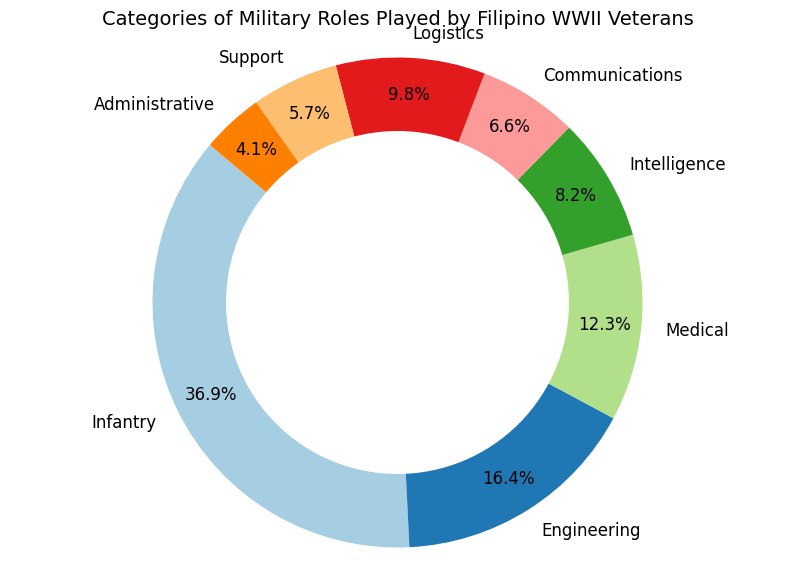Which category has the highest percentage of roles played by Filipino WWII veterans? By looking at the pie chart, the category with the largest segment represents the highest percentage. In this case, it is the Infantry category.
Answer: Infantry Which categories together compose roughly half of the total roles? Adding the percentages of the two largest segments, Infantry (45%) and Engineering (20%), gives us 65%. So, Infantry and Engineering together exceed half. Narrowing down, Infantry (45%) plus Medical (15%) equals 60%, while Infantry (45%) plus Intelligence (10%) equals 55%. Thus, Infantry (45%) plus Medical (15%) or Infantry (45%) plus Intelligence (10%) together each exceed half.
Answer: Infantry and Medical Which category has the smallest percentage of roles played? The smallest segment in the pie chart represents the category with the smallest percentage. This category is Administrative.
Answer: Administrative How much larger is the percentage of Infantry roles compared to Medical roles? The percentage of Infantry roles is 45%, and the percentage of Medical roles is 15%. Subtracting these gives us: 45% - 15% = 30%.
Answer: 30% What is the combined percentage for Communications, Logistics, and Support roles? Adding the percentages for Communications (8%), Logistics (12%), and Support (7%): 8% + 12% + 7% = 27%.
Answer: 27% Which two categories together have a percentage less than that of the Infantry category alone? First, identify the percentages of each category: Engineering (20%), Medical (15%), Intelligence (10%), Communications (8%), Logistics (12%), Support (7%), Administrative (5%). Combining categories that sum to less than 45%: e.g., Communications (8%) and Support (7%) sum to 15%, which is less than 45%. However, Engineering (20%) and Medical (15%) sum to 35%, also less than 45%. Many pairs can be chosen, such as Communications and Support (15%), Medical and Communications (23%), etc.
Answer: Engineering and Medical Which two categories, when combined, equal the percentage of Logistics roles? The percentage of Logistics roles is 12%. Combining Support (7%) and Administrative (5%) equals 7% + 5% = 12%.
Answer: Support and Administrative 